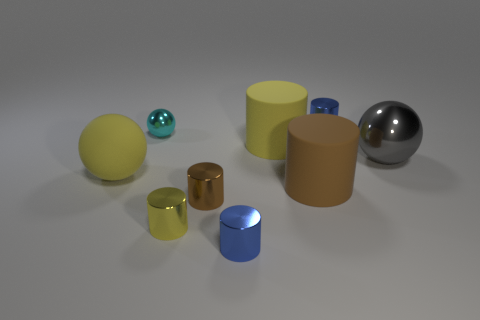Does the cyan metallic ball have the same size as the brown metallic cylinder that is in front of the yellow sphere?
Your answer should be compact. Yes. How many matte objects are tiny brown objects or brown cylinders?
Ensure brevity in your answer.  1. What number of blue things have the same shape as the cyan metallic thing?
Offer a terse response. 0. There is a big cylinder that is the same color as the matte ball; what is its material?
Ensure brevity in your answer.  Rubber. There is a blue metallic cylinder that is in front of the large brown rubber cylinder; is it the same size as the yellow rubber object that is behind the large matte ball?
Offer a terse response. No. There is a small metallic object in front of the tiny yellow cylinder; what shape is it?
Ensure brevity in your answer.  Cylinder. There is a small yellow thing that is the same shape as the brown metallic object; what material is it?
Ensure brevity in your answer.  Metal. Is the size of the blue shiny object right of the yellow rubber cylinder the same as the tiny yellow metallic cylinder?
Make the answer very short. Yes. How many big matte objects are to the right of the brown matte thing?
Your answer should be very brief. 0. Are there fewer small yellow things that are to the right of the tiny brown thing than small metallic balls to the right of the tiny cyan ball?
Your response must be concise. No. 